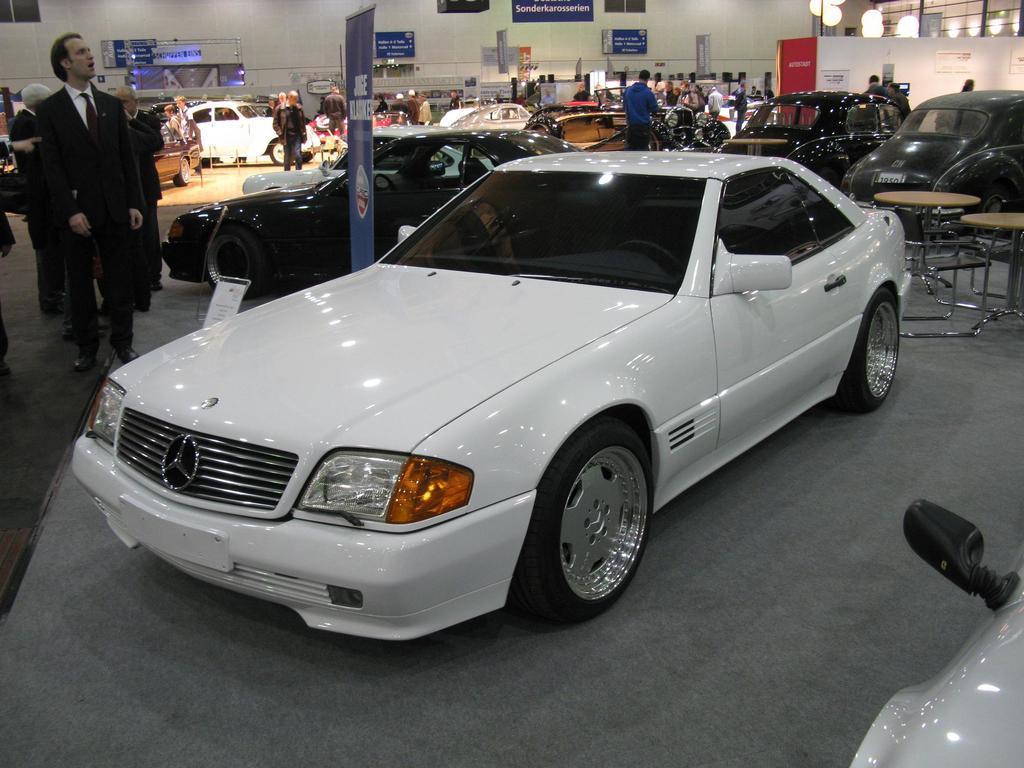Can you describe this image briefly? In this image, there are few people standing. This picture was taken in the car show. I can see different types of cars. On the right side of the image, there are tables and chairs. I can see a banner, which is between the two cars. In the background, I can see the name boards and lights. At the bottom right corner of the image, I can see another vehicle. 